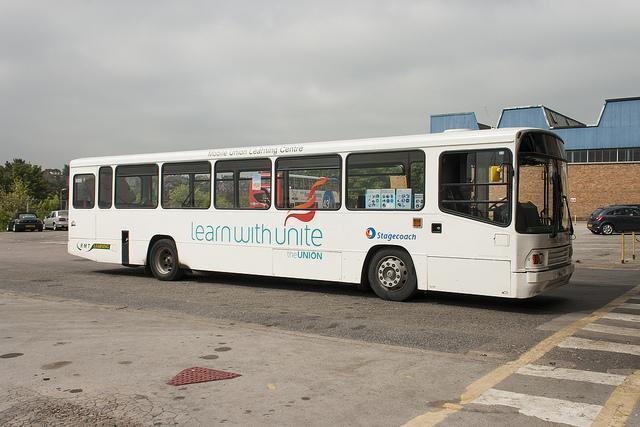How many people are on the bus?
Give a very brief answer. 0. How many wheels does the bus have?
Give a very brief answer. 2. 